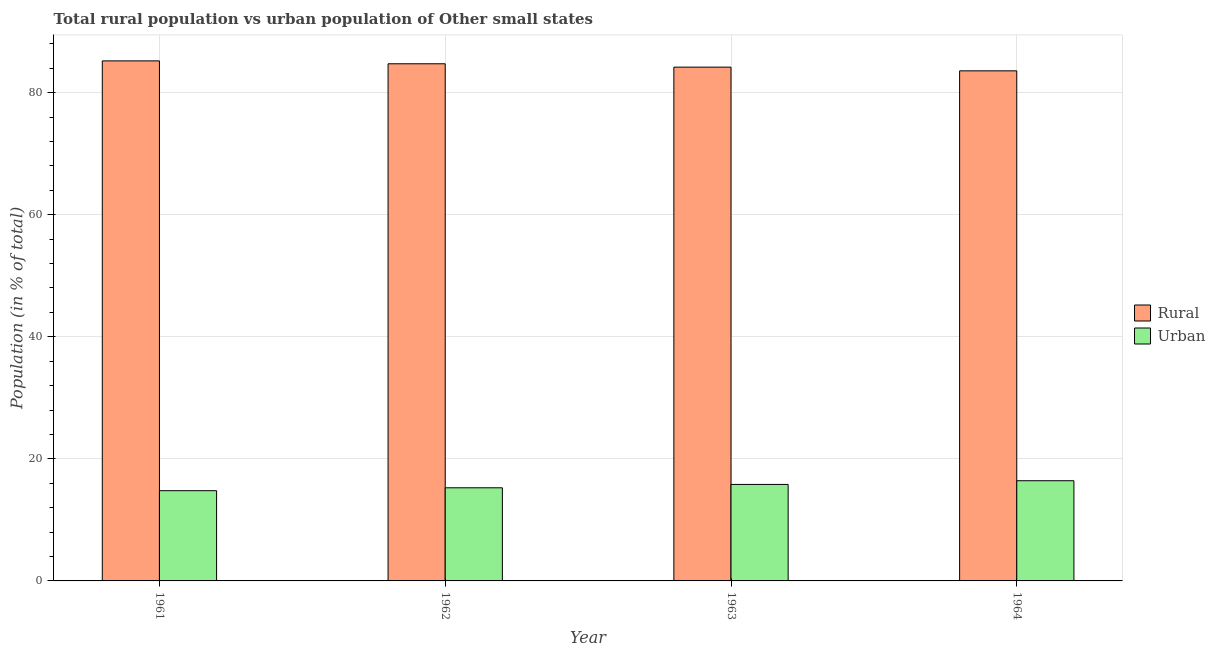How many different coloured bars are there?
Offer a very short reply. 2. Are the number of bars on each tick of the X-axis equal?
Offer a terse response. Yes. What is the label of the 3rd group of bars from the left?
Provide a succinct answer. 1963. What is the urban population in 1962?
Your answer should be compact. 15.26. Across all years, what is the maximum urban population?
Make the answer very short. 16.42. Across all years, what is the minimum rural population?
Ensure brevity in your answer.  83.58. In which year was the urban population maximum?
Give a very brief answer. 1964. In which year was the rural population minimum?
Offer a terse response. 1964. What is the total urban population in the graph?
Your answer should be very brief. 62.27. What is the difference between the urban population in 1961 and that in 1962?
Offer a very short reply. -0.47. What is the difference between the urban population in 1962 and the rural population in 1961?
Ensure brevity in your answer.  0.47. What is the average rural population per year?
Ensure brevity in your answer.  84.43. What is the ratio of the rural population in 1962 to that in 1963?
Your response must be concise. 1.01. Is the rural population in 1962 less than that in 1963?
Provide a succinct answer. No. Is the difference between the urban population in 1962 and 1964 greater than the difference between the rural population in 1962 and 1964?
Your answer should be very brief. No. What is the difference between the highest and the second highest urban population?
Your answer should be very brief. 0.61. What is the difference between the highest and the lowest urban population?
Keep it short and to the point. 1.63. Is the sum of the rural population in 1961 and 1962 greater than the maximum urban population across all years?
Give a very brief answer. Yes. What does the 1st bar from the left in 1963 represents?
Offer a very short reply. Rural. What does the 1st bar from the right in 1964 represents?
Your answer should be very brief. Urban. Does the graph contain any zero values?
Ensure brevity in your answer.  No. Does the graph contain grids?
Make the answer very short. Yes. Where does the legend appear in the graph?
Provide a succinct answer. Center right. What is the title of the graph?
Ensure brevity in your answer.  Total rural population vs urban population of Other small states. Does "Primary completion rate" appear as one of the legend labels in the graph?
Your response must be concise. No. What is the label or title of the Y-axis?
Keep it short and to the point. Population (in % of total). What is the Population (in % of total) in Rural in 1961?
Make the answer very short. 85.21. What is the Population (in % of total) in Urban in 1961?
Ensure brevity in your answer.  14.79. What is the Population (in % of total) in Rural in 1962?
Provide a succinct answer. 84.74. What is the Population (in % of total) of Urban in 1962?
Offer a terse response. 15.26. What is the Population (in % of total) of Rural in 1963?
Give a very brief answer. 84.19. What is the Population (in % of total) of Urban in 1963?
Give a very brief answer. 15.81. What is the Population (in % of total) of Rural in 1964?
Your answer should be compact. 83.58. What is the Population (in % of total) in Urban in 1964?
Keep it short and to the point. 16.42. Across all years, what is the maximum Population (in % of total) in Rural?
Your answer should be compact. 85.21. Across all years, what is the maximum Population (in % of total) in Urban?
Your response must be concise. 16.42. Across all years, what is the minimum Population (in % of total) in Rural?
Keep it short and to the point. 83.58. Across all years, what is the minimum Population (in % of total) in Urban?
Offer a very short reply. 14.79. What is the total Population (in % of total) of Rural in the graph?
Offer a very short reply. 337.73. What is the total Population (in % of total) of Urban in the graph?
Make the answer very short. 62.27. What is the difference between the Population (in % of total) of Rural in 1961 and that in 1962?
Provide a short and direct response. 0.47. What is the difference between the Population (in % of total) of Urban in 1961 and that in 1962?
Provide a succinct answer. -0.47. What is the difference between the Population (in % of total) of Rural in 1961 and that in 1963?
Offer a terse response. 1.02. What is the difference between the Population (in % of total) in Urban in 1961 and that in 1963?
Make the answer very short. -1.02. What is the difference between the Population (in % of total) in Rural in 1961 and that in 1964?
Ensure brevity in your answer.  1.63. What is the difference between the Population (in % of total) of Urban in 1961 and that in 1964?
Make the answer very short. -1.63. What is the difference between the Population (in % of total) in Rural in 1962 and that in 1963?
Give a very brief answer. 0.55. What is the difference between the Population (in % of total) in Urban in 1962 and that in 1963?
Ensure brevity in your answer.  -0.55. What is the difference between the Population (in % of total) in Rural in 1962 and that in 1964?
Ensure brevity in your answer.  1.16. What is the difference between the Population (in % of total) of Urban in 1962 and that in 1964?
Provide a short and direct response. -1.16. What is the difference between the Population (in % of total) in Rural in 1963 and that in 1964?
Make the answer very short. 0.61. What is the difference between the Population (in % of total) in Urban in 1963 and that in 1964?
Give a very brief answer. -0.61. What is the difference between the Population (in % of total) in Rural in 1961 and the Population (in % of total) in Urban in 1962?
Ensure brevity in your answer.  69.95. What is the difference between the Population (in % of total) of Rural in 1961 and the Population (in % of total) of Urban in 1963?
Provide a succinct answer. 69.4. What is the difference between the Population (in % of total) of Rural in 1961 and the Population (in % of total) of Urban in 1964?
Keep it short and to the point. 68.8. What is the difference between the Population (in % of total) in Rural in 1962 and the Population (in % of total) in Urban in 1963?
Your response must be concise. 68.93. What is the difference between the Population (in % of total) of Rural in 1962 and the Population (in % of total) of Urban in 1964?
Your answer should be very brief. 68.32. What is the difference between the Population (in % of total) of Rural in 1963 and the Population (in % of total) of Urban in 1964?
Offer a very short reply. 67.77. What is the average Population (in % of total) of Rural per year?
Make the answer very short. 84.43. What is the average Population (in % of total) of Urban per year?
Your answer should be very brief. 15.57. In the year 1961, what is the difference between the Population (in % of total) of Rural and Population (in % of total) of Urban?
Make the answer very short. 70.43. In the year 1962, what is the difference between the Population (in % of total) in Rural and Population (in % of total) in Urban?
Your response must be concise. 69.48. In the year 1963, what is the difference between the Population (in % of total) in Rural and Population (in % of total) in Urban?
Make the answer very short. 68.38. In the year 1964, what is the difference between the Population (in % of total) of Rural and Population (in % of total) of Urban?
Your answer should be compact. 67.17. What is the ratio of the Population (in % of total) of Rural in 1961 to that in 1962?
Ensure brevity in your answer.  1.01. What is the ratio of the Population (in % of total) in Urban in 1961 to that in 1962?
Provide a short and direct response. 0.97. What is the ratio of the Population (in % of total) in Rural in 1961 to that in 1963?
Keep it short and to the point. 1.01. What is the ratio of the Population (in % of total) in Urban in 1961 to that in 1963?
Ensure brevity in your answer.  0.94. What is the ratio of the Population (in % of total) of Rural in 1961 to that in 1964?
Offer a terse response. 1.02. What is the ratio of the Population (in % of total) of Urban in 1961 to that in 1964?
Make the answer very short. 0.9. What is the ratio of the Population (in % of total) of Urban in 1962 to that in 1963?
Give a very brief answer. 0.97. What is the ratio of the Population (in % of total) of Rural in 1962 to that in 1964?
Provide a succinct answer. 1.01. What is the ratio of the Population (in % of total) of Urban in 1962 to that in 1964?
Your answer should be compact. 0.93. What is the ratio of the Population (in % of total) of Rural in 1963 to that in 1964?
Your response must be concise. 1.01. What is the ratio of the Population (in % of total) in Urban in 1963 to that in 1964?
Your answer should be very brief. 0.96. What is the difference between the highest and the second highest Population (in % of total) in Rural?
Make the answer very short. 0.47. What is the difference between the highest and the second highest Population (in % of total) of Urban?
Give a very brief answer. 0.61. What is the difference between the highest and the lowest Population (in % of total) of Rural?
Your answer should be very brief. 1.63. What is the difference between the highest and the lowest Population (in % of total) in Urban?
Provide a succinct answer. 1.63. 